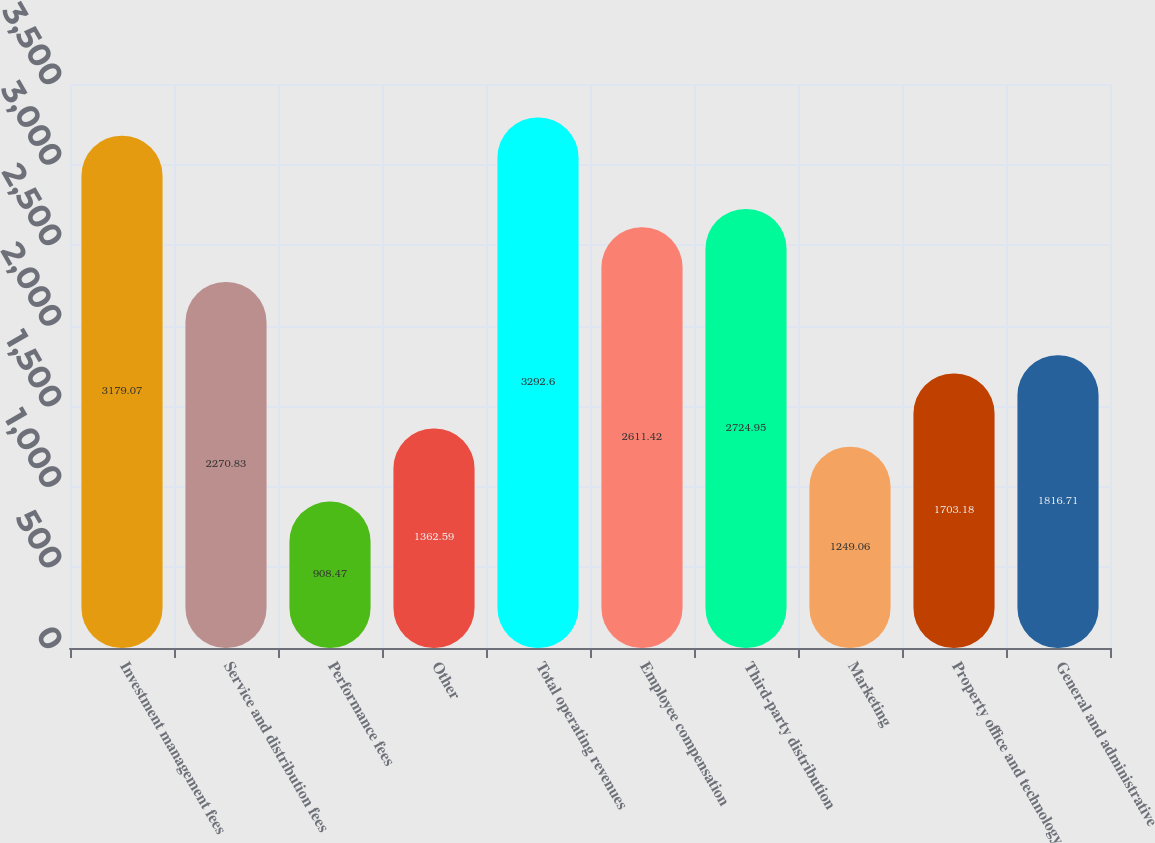Convert chart. <chart><loc_0><loc_0><loc_500><loc_500><bar_chart><fcel>Investment management fees<fcel>Service and distribution fees<fcel>Performance fees<fcel>Other<fcel>Total operating revenues<fcel>Employee compensation<fcel>Third-party distribution<fcel>Marketing<fcel>Property office and technology<fcel>General and administrative<nl><fcel>3179.07<fcel>2270.83<fcel>908.47<fcel>1362.59<fcel>3292.6<fcel>2611.42<fcel>2724.95<fcel>1249.06<fcel>1703.18<fcel>1816.71<nl></chart> 